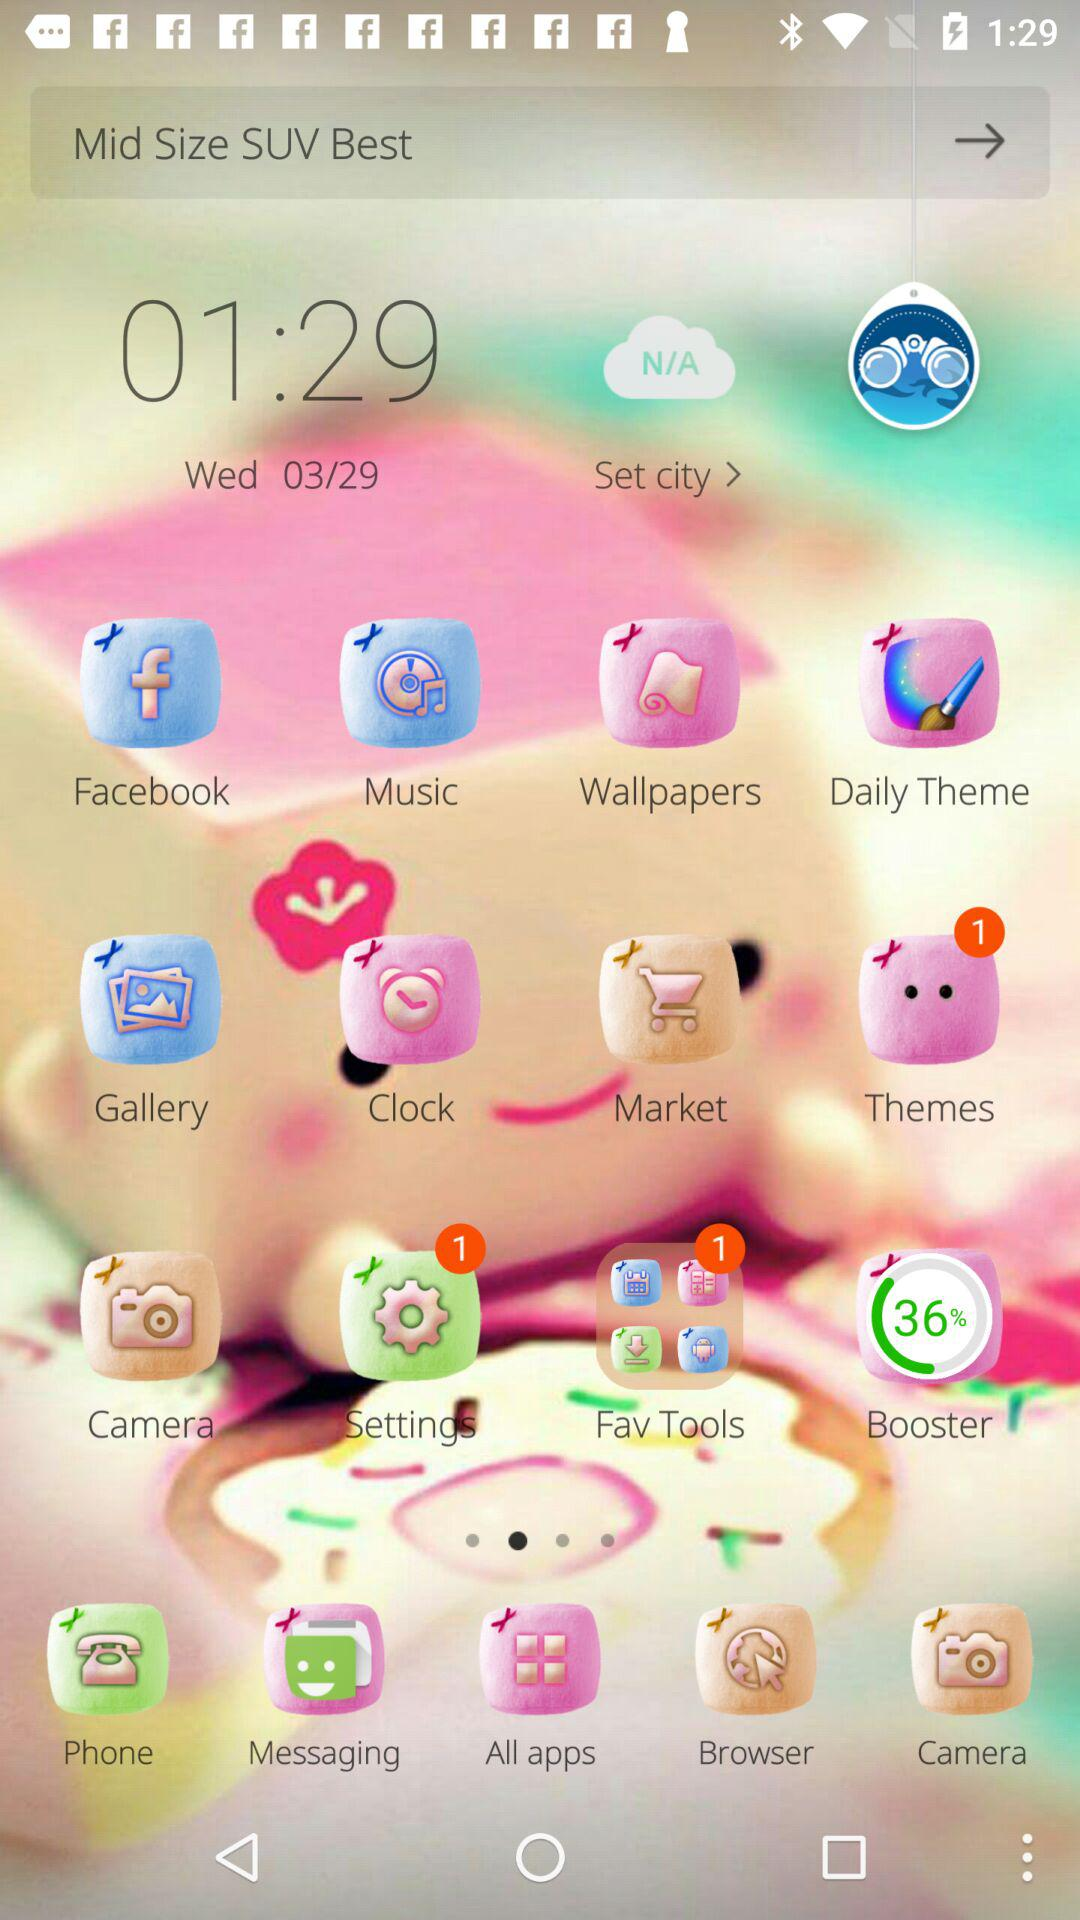What day is it on March 29? The day is Wednesday. 